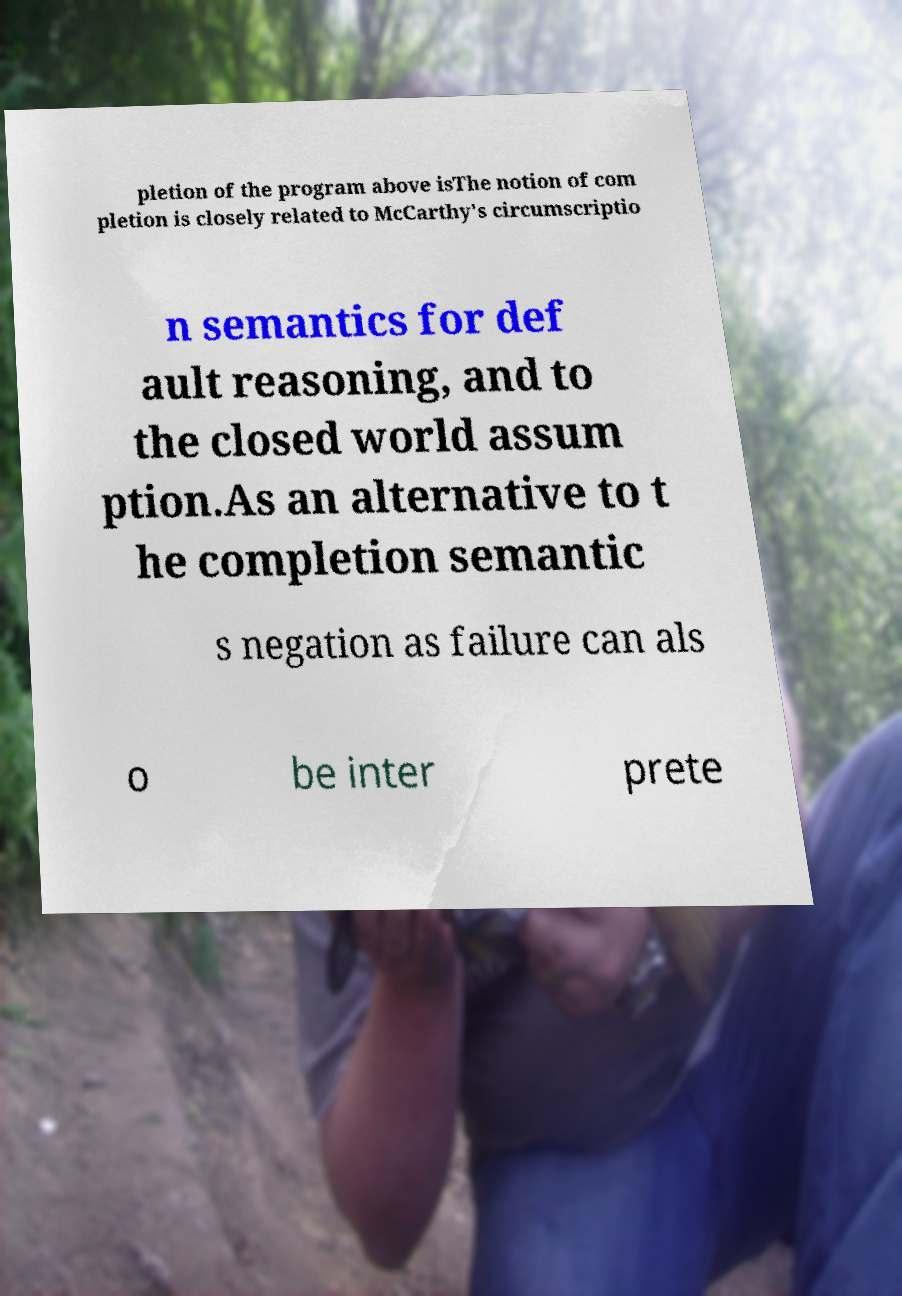Please read and relay the text visible in this image. What does it say? pletion of the program above isThe notion of com pletion is closely related to McCarthy's circumscriptio n semantics for def ault reasoning, and to the closed world assum ption.As an alternative to t he completion semantic s negation as failure can als o be inter prete 